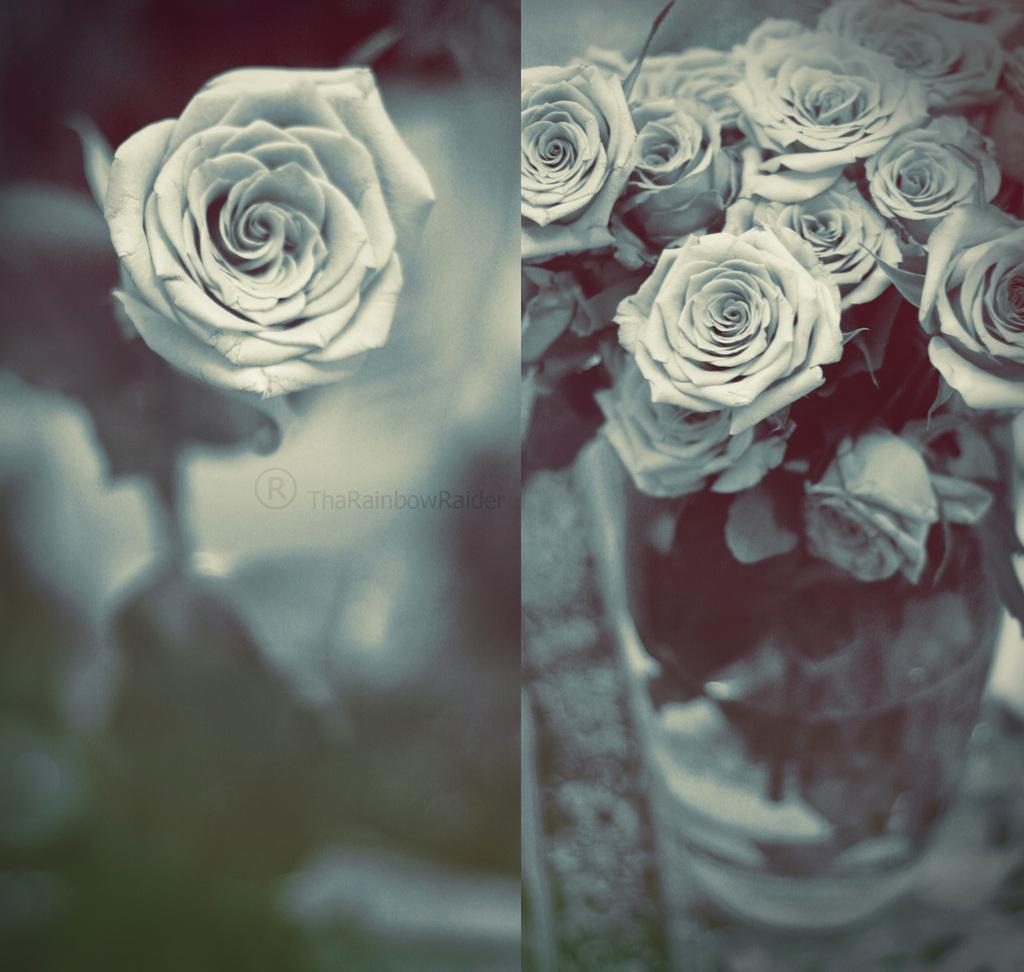What type of plants can be seen in the image? There are flowers in the image. What is the main feature of the collage image in the picture? The collage image is not described in the facts, so we cannot answer this question definitively. Where is the vase located in the image? The vase is at the right side of the image. How would you describe the background at the left side of the image? The background at the left side of the image is blurred. What type of quilt is being used to cover the memory in the image? There is no quilt or memory present in the image; it features flowers, a collage image, a vase, and a blurred background. How many steps are visible in the image? There is no mention of steps in the image, so we cannot answer this question definitively. 